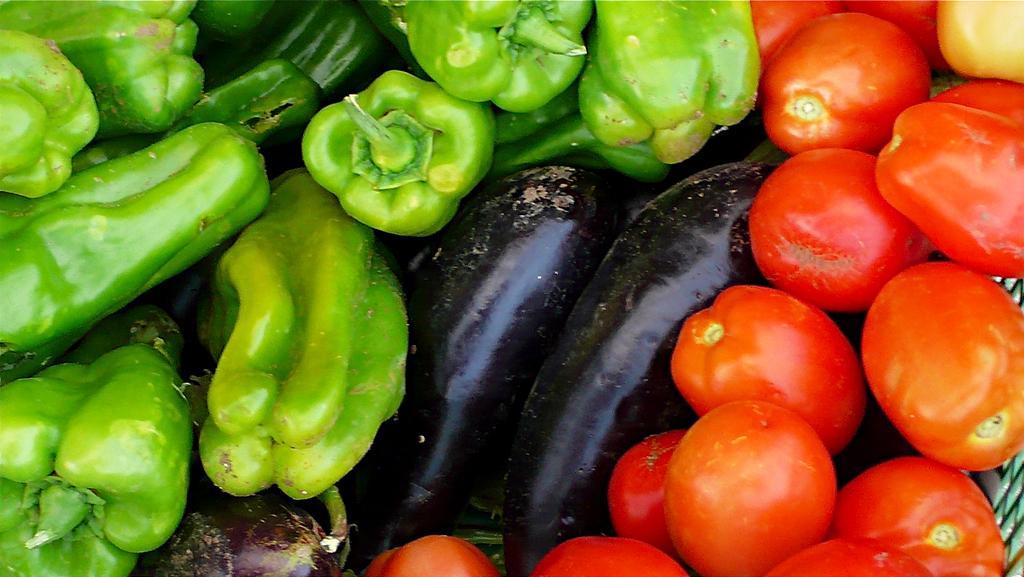Describe this image in one or two sentences. In the image in the center we can see different type of vegetables like tomatoes,capsicums and aubergines. 